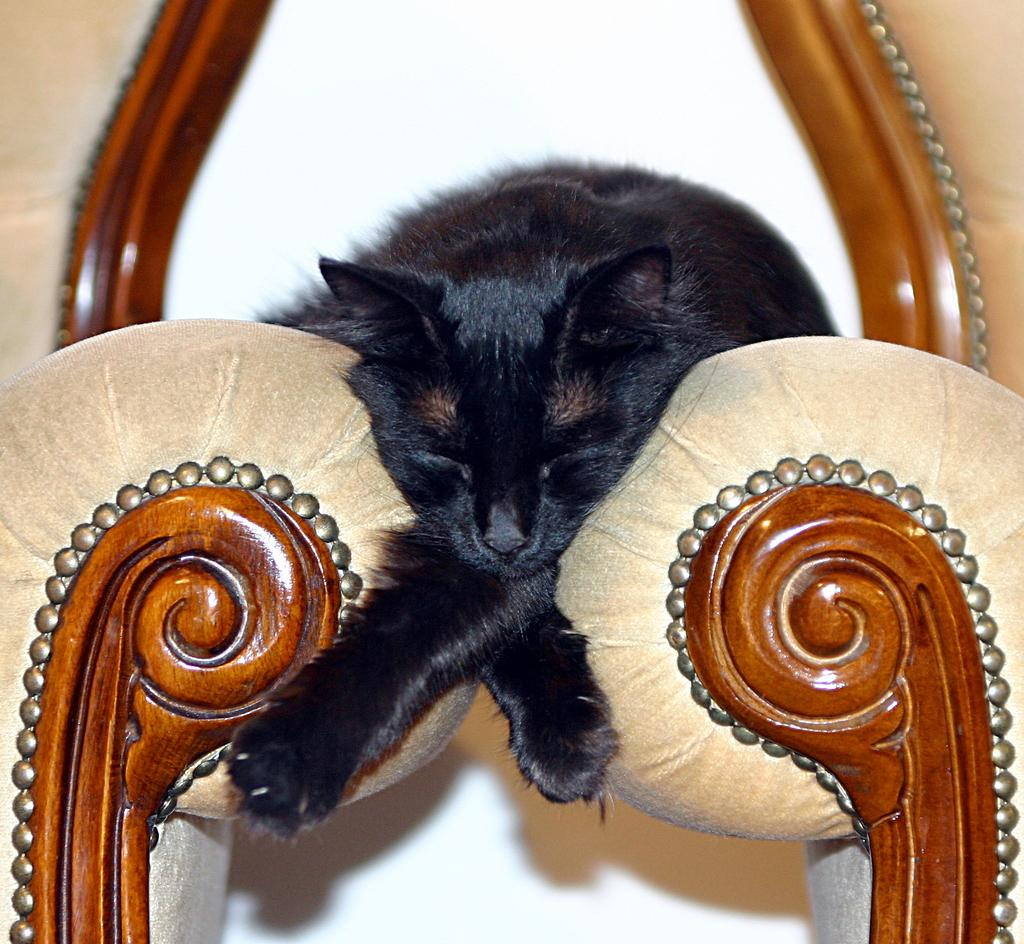What type of animal is in the image? There is a black cat in the image. Can you describe the position of the cat in relation to other objects? The cat is positioned between objects in the image. What educational story is the cat reading in the image? There is no educational story or reading material present in the image; the cat is simply positioned between objects. 